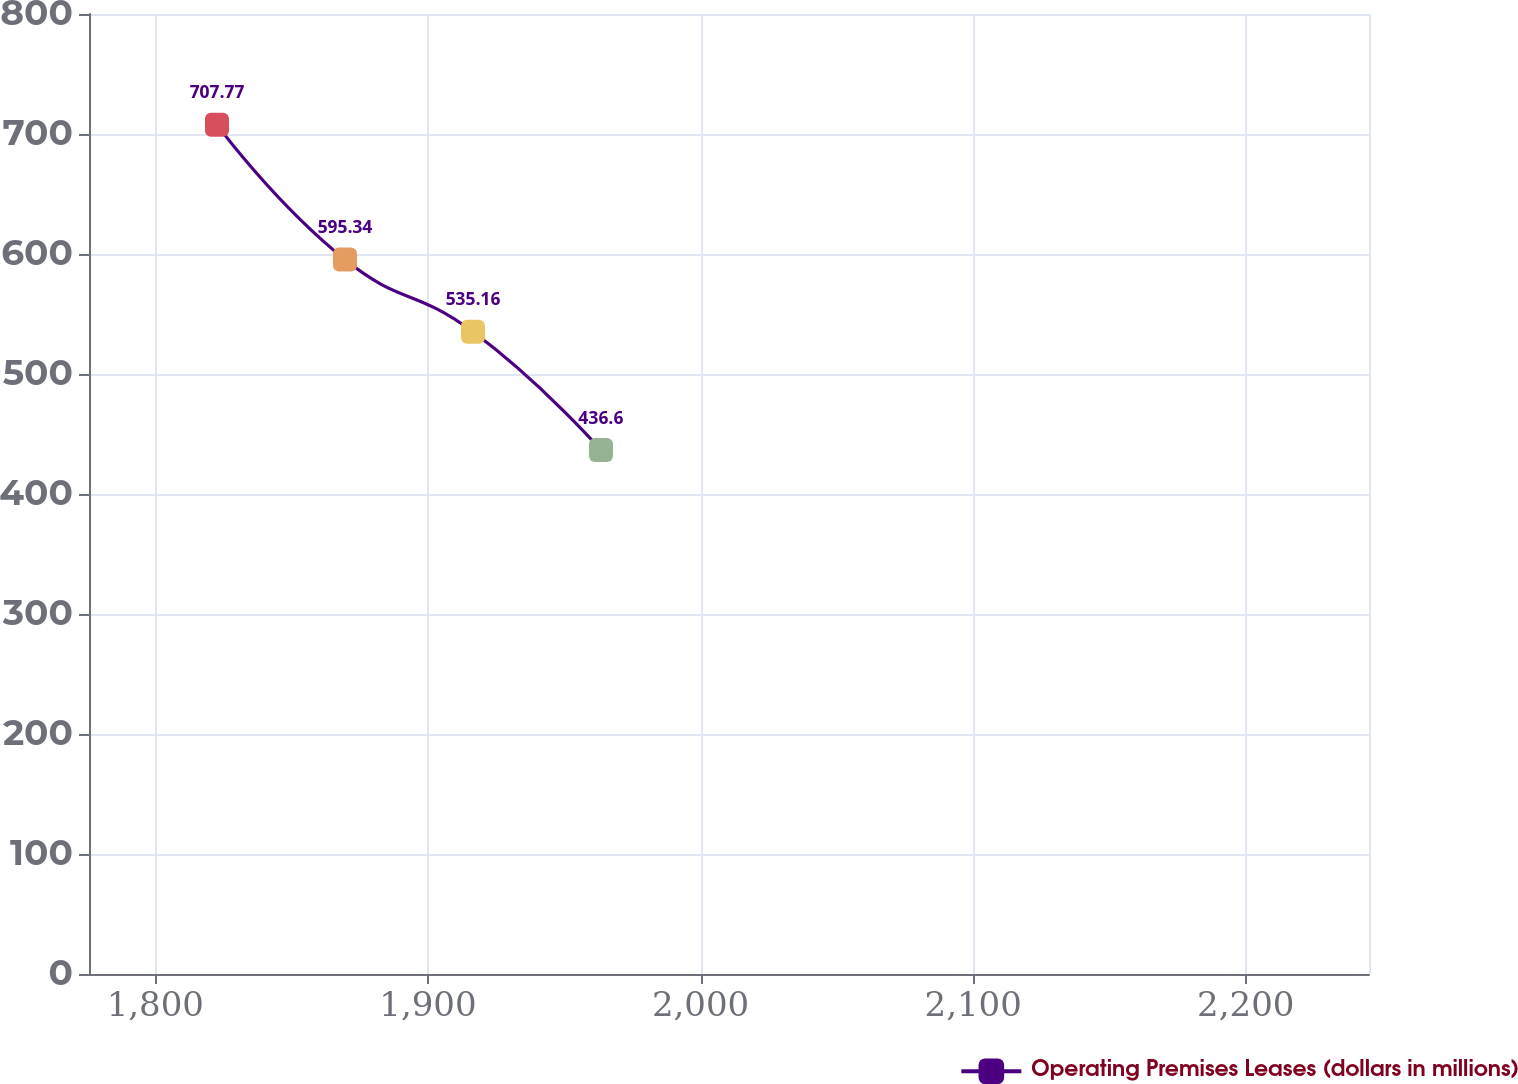Convert chart to OTSL. <chart><loc_0><loc_0><loc_500><loc_500><line_chart><ecel><fcel>Operating Premises Leases (dollars in millions)<nl><fcel>1822.63<fcel>707.77<nl><fcel>1869.58<fcel>595.34<nl><fcel>1916.53<fcel>535.16<nl><fcel>1963.48<fcel>436.6<nl><fcel>2292.15<fcel>358.17<nl></chart> 